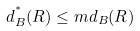Convert formula to latex. <formula><loc_0><loc_0><loc_500><loc_500>d ^ { ^ { * } } _ { B } ( R ) \leq m d _ { B } ( R )</formula> 